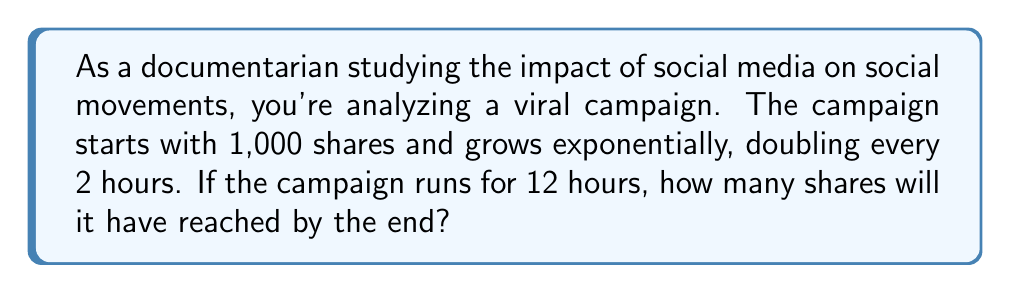Could you help me with this problem? Let's approach this step-by-step:

1) First, we need to identify the key components of exponential growth:
   - Initial value: $a = 1,000$ shares
   - Growth factor: doubles (×2) every 2 hours
   - Time: 12 hours total

2) We can express this using the exponential growth formula:
   $$ A = a \cdot r^n $$
   Where:
   $A$ = final amount
   $a$ = initial amount
   $r$ = growth factor per period
   $n$ = number of periods

3) In this case:
   $a = 1,000$
   $r = 2$ (doubles each period)
   
   To find $n$, we need to determine how many 2-hour periods are in 12 hours:
   $n = 12 \div 2 = 6$ periods

4) Now we can plug these values into our formula:
   $$ A = 1,000 \cdot 2^6 $$

5) Calculate $2^6$:
   $$ 2^6 = 2 \times 2 \times 2 \times 2 \times 2 \times 2 = 64 $$

6) Finally, multiply:
   $$ A = 1,000 \times 64 = 64,000 $$

Therefore, after 12 hours, the campaign will have reached 64,000 shares.
Answer: 64,000 shares 